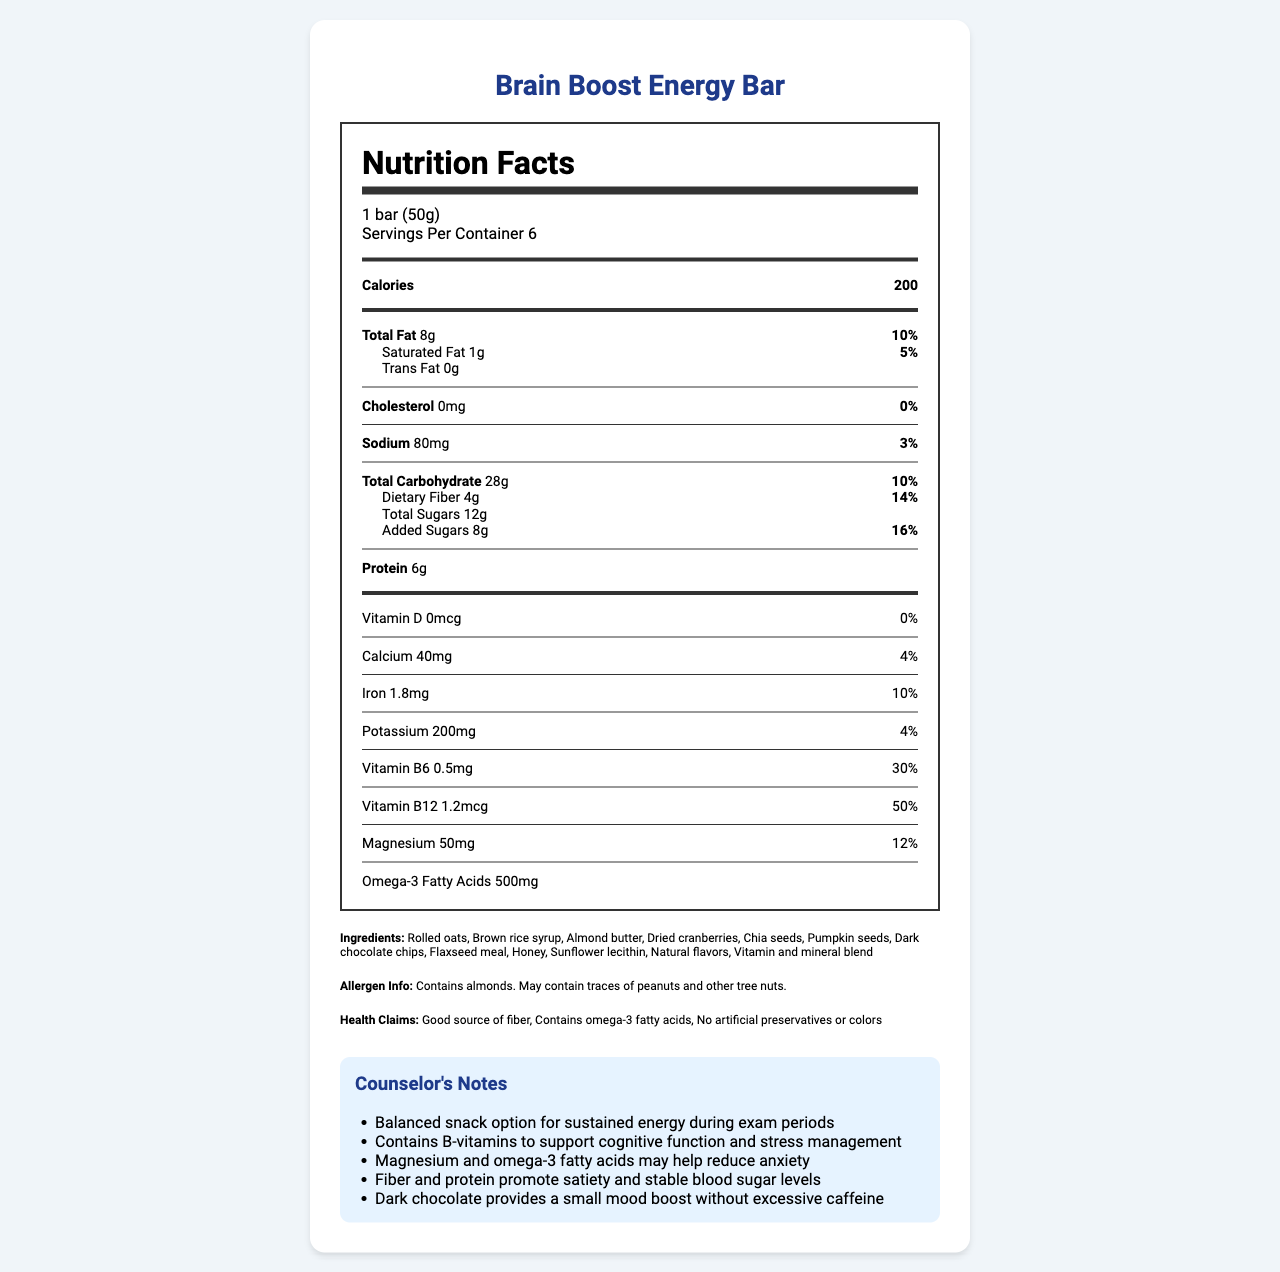what is the serving size of the Brain Boost Energy Bar? The serving size is mentioned in the document under the "serving size" section.
Answer: 1 bar (50g) how many calories are in one serving? The calorie content per serving is listed under "Calories" in the nutrition facts.
Answer: 200 what percentage of the daily value of Vitamin B12 does one bar provide? The daily value percentage is listed next to Vitamin B12 in the document.
Answer: 50% how much dietary fiber is in one serving? The amount of dietary fiber per serving is listed under the "Total Carbohydrate" section.
Answer: 4g are there any artificial preservatives or colors in the Brain Boost Energy Bar? The document states "No artificial preservatives or colors" under "Health Claims."
Answer: No which nutrient has the highest daily value percentage? A. Calcium B. Vitamin B6 C. Magnesium D. Vitamin B12 Vitamin B12 has a daily value percentage of 50%, which is the highest among the listed nutrients.
Answer: D. Vitamin B12 what is the main ingredient in the Brain Boost Energy Bar? A. Almond butter B. Rolled oats C. Chia seeds D. Dark chocolate chips The ingredients are listed in order of predominance, and rolled oats is the first ingredient mentioned.
Answer: B. Rolled oats does the Brain Boost Energy Bar contain any allergens? The allergen information states that it contains almonds and may contain traces of peanuts and other tree nuts.
Answer: Yes is there any cholesterol in the Brain Boost Energy Bar? The document states "Cholesterol 0mg," indicating there is no cholesterol in the bar.
Answer: No what are some health benefits mentioned in the counselor's notes? The counselor's notes list several health benefits of the Brain Boost Energy Bar.
Answer: Balanced snack, supports cognitive function, stress management, reduces anxiety, promotes satiety, stable blood sugar levels, mood boost how much protein is in one bar? The protein content per serving is listed under "Protein" in the nutrition facts.
Answer: 6g does the Brain Boost Energy Bar contain any artificial colors? Under Health Claims, it states, "No artificial preservatives or colors."
Answer: No what is the potassium content in one serving? The amount of potassium per serving is listed under "Potassium" in the nutrition facts.
Answer: 200mg summarize the main idea of the document The document summarizes the nutritional content and health benefits of the Brain Boost Energy Bar, emphasizing its suitability as a healthy snack for students.
Answer: The document provides the nutrition facts of the Brain Boost Energy Bar, a snack recommended for stressed students during exam periods. It includes detailed nutritional information, ingredient list, allergen info, health claims, and the counselor's notes on its benefits for cognitive function, stress management, and overall well-being. what is the source of omega-3 fatty acids in the Brain Boost Energy Bar? The document lists the amount of omega-3 fatty acids but does not specify the source.
Answer: Not enough information 